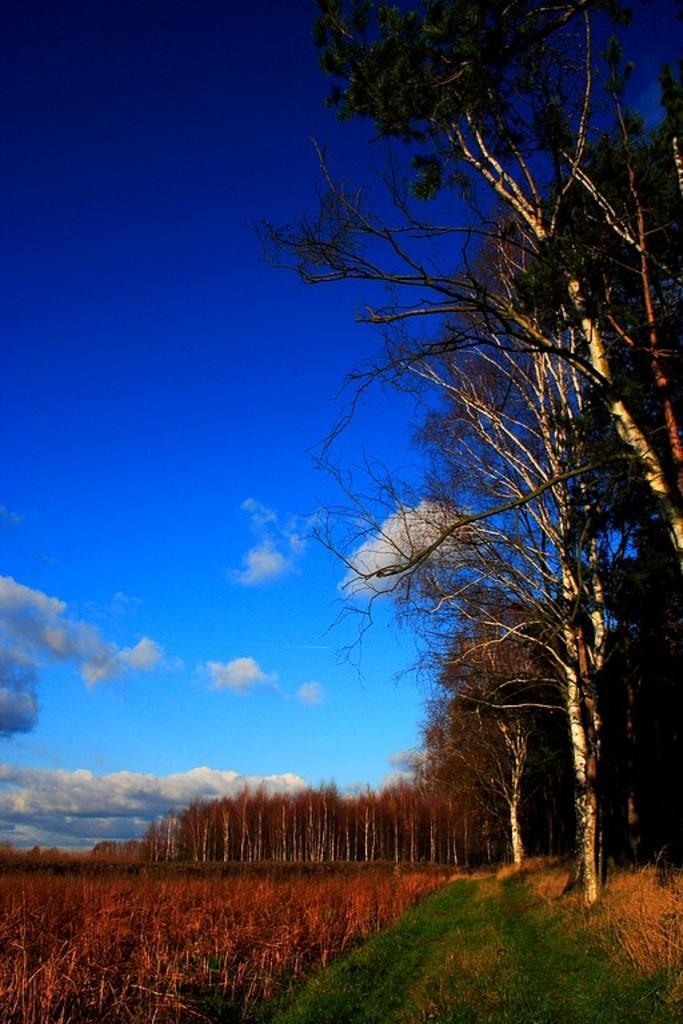In one or two sentences, can you explain what this image depicts? This image is taken outdoors. At the top of the image there is a sky with clouds. At the bottom of the image there is a ground with grass and plants. On the left side of the image there are many trees. 